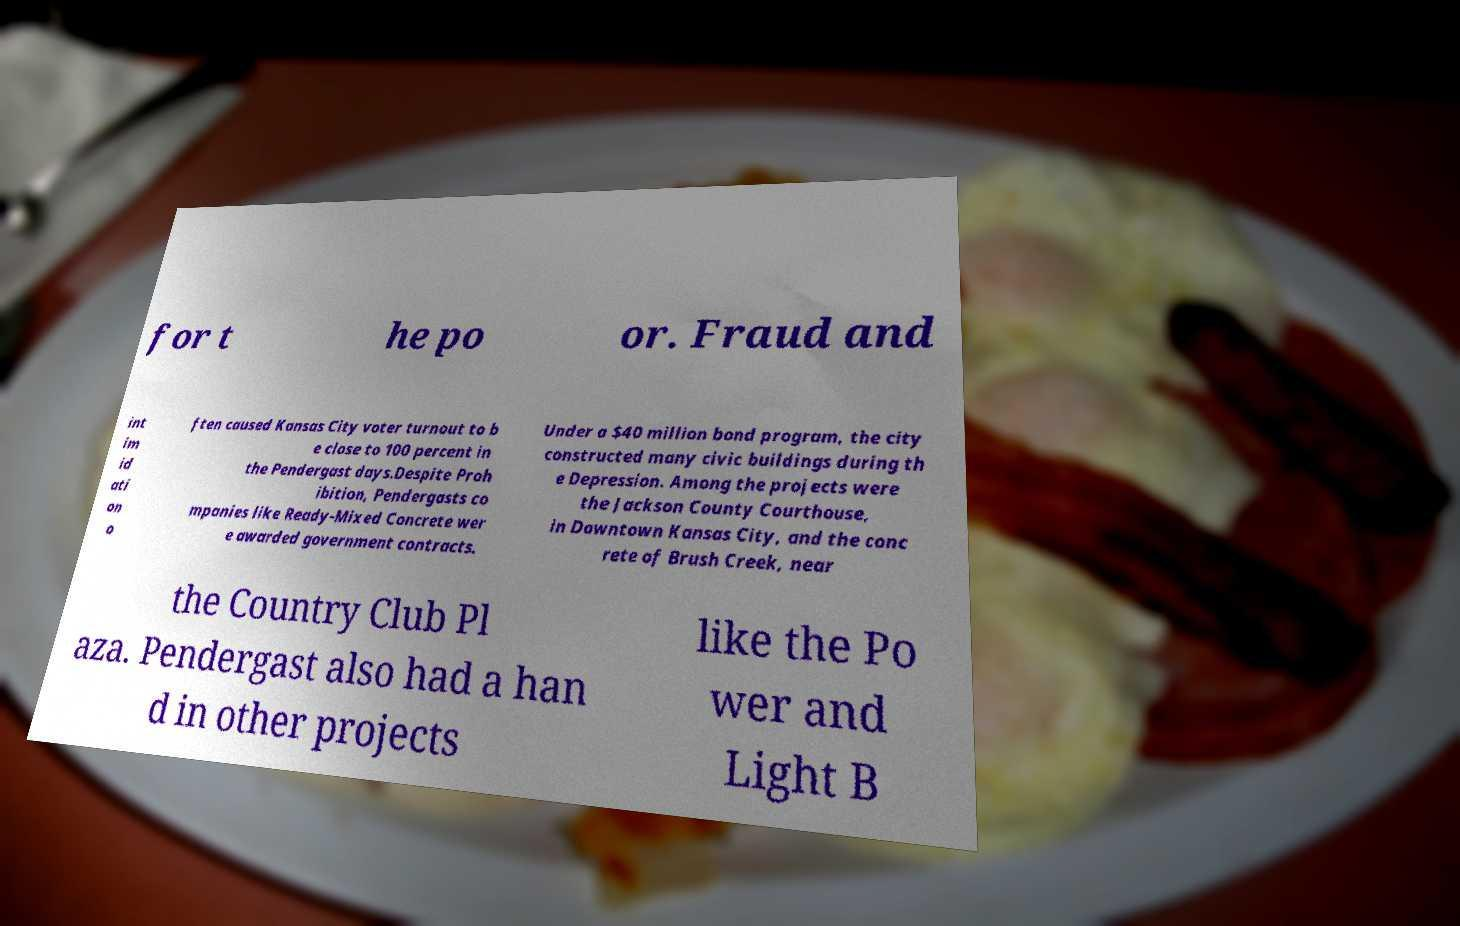For documentation purposes, I need the text within this image transcribed. Could you provide that? for t he po or. Fraud and int im id ati on o ften caused Kansas City voter turnout to b e close to 100 percent in the Pendergast days.Despite Proh ibition, Pendergasts co mpanies like Ready-Mixed Concrete wer e awarded government contracts. Under a $40 million bond program, the city constructed many civic buildings during th e Depression. Among the projects were the Jackson County Courthouse, in Downtown Kansas City, and the conc rete of Brush Creek, near the Country Club Pl aza. Pendergast also had a han d in other projects like the Po wer and Light B 